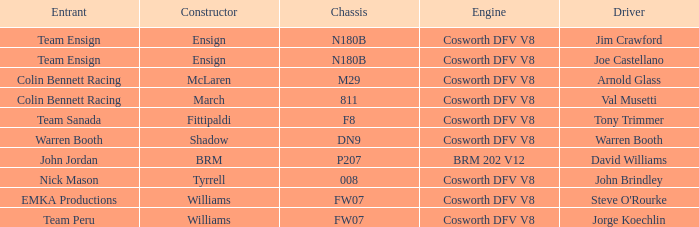Who constructed warren booth's automobile with the cosworth dfv v8 motor? Shadow. 